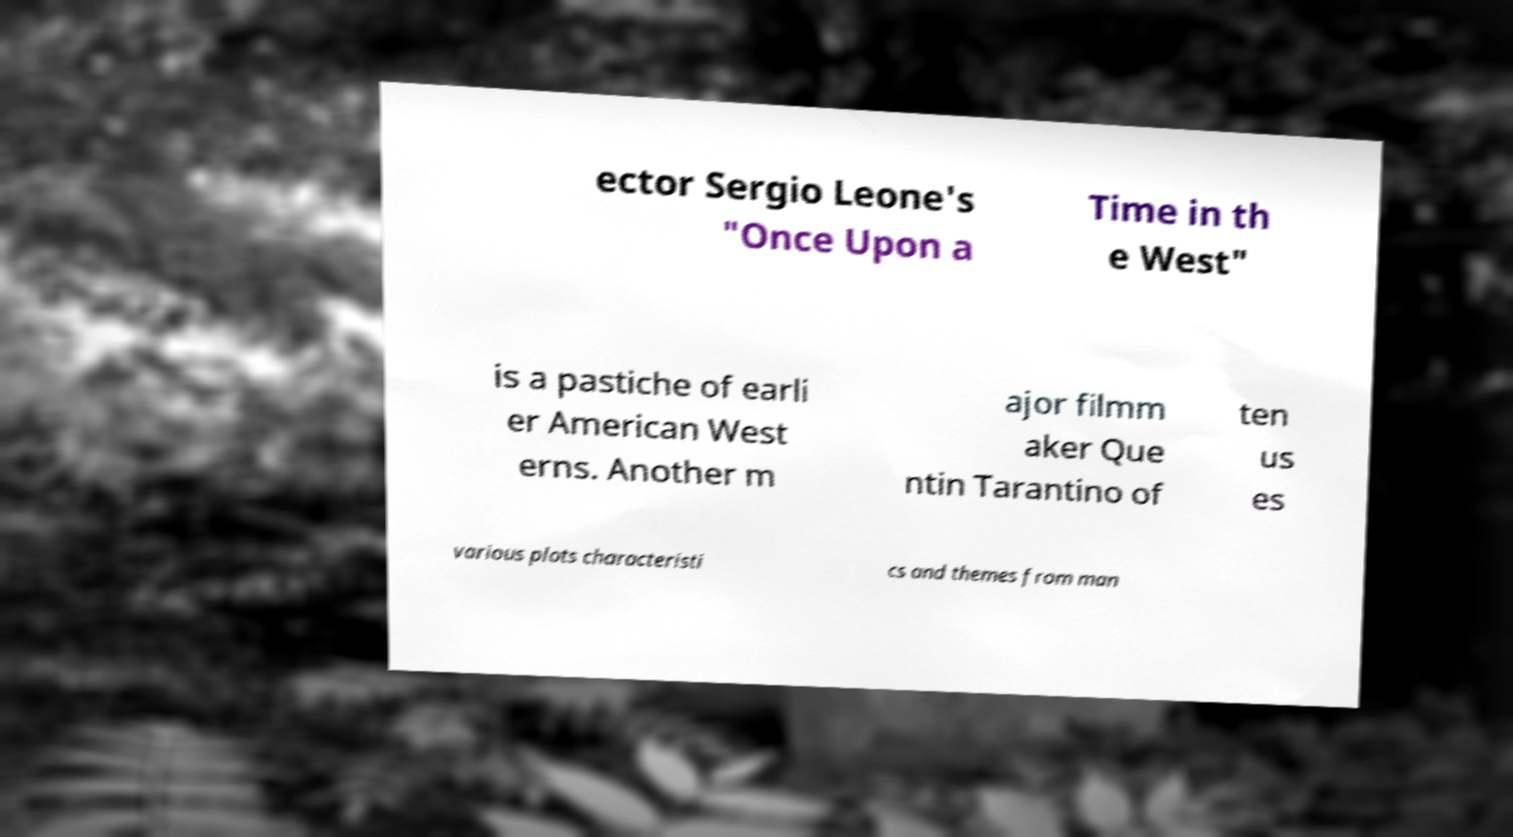There's text embedded in this image that I need extracted. Can you transcribe it verbatim? ector Sergio Leone's "Once Upon a Time in th e West" is a pastiche of earli er American West erns. Another m ajor filmm aker Que ntin Tarantino of ten us es various plots characteristi cs and themes from man 